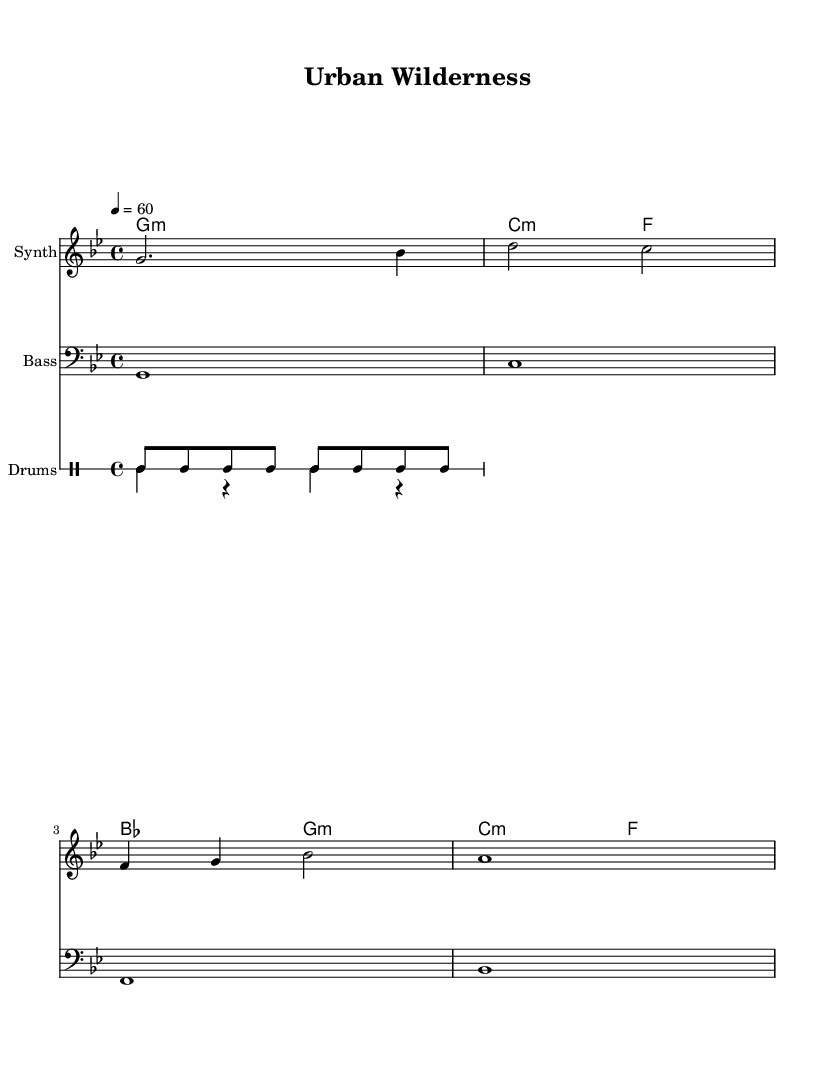What is the key signature of this music? The key signature is G minor, which includes two flats (B flat and E flat) in its scale. This can be confirmed by looking at the key signature indicated at the beginning of the staff.
Answer: G minor What is the time signature of this music? The time signature is 4/4, which means there are four beats in each measure, and the quarter note gets one beat. This can be seen at the beginning of the score where the time signature is notated.
Answer: 4/4 What is the tempo marking of this music? The tempo marking is 60 beats per minute, indicated by the text "4 = 60" which suggests the quarter note is the unit for the pulse in the music.
Answer: 60 How many distinct instruments are used in this score? There are three distinct instruments: the Synth, Bass, and Drums. This can be identified by the different staves labeled for each type of instrument throughout the score.
Answer: Three Which chord is played in the first measure? The chord in the first measure is G minor, represented by the chord symbol "g:m" above the staff. This shows that the harmony played corresponds to the G minor chord in that measure.
Answer: G minor How many distinct drum patterns are present in this music? There are two distinct drum patterns: one for the high-hat (drumPatternUp) and the other for the bass and snare (drumPatternDown). These can be identified by the different drummode notations provided for each pattern in the score.
Answer: Two What is the final note of the melody? The final note of the melody is A, as it is notated at the end of the melody section. This is determined by examining the last note symbol in the melody line.
Answer: A 